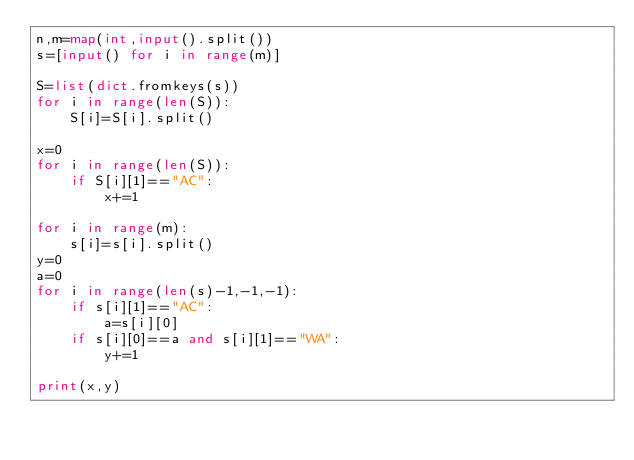<code> <loc_0><loc_0><loc_500><loc_500><_Python_>n,m=map(int,input().split())
s=[input() for i in range(m)]

S=list(dict.fromkeys(s))
for i in range(len(S)):
    S[i]=S[i].split()

x=0
for i in range(len(S)):
    if S[i][1]=="AC":
        x+=1

for i in range(m):
    s[i]=s[i].split()
y=0
a=0
for i in range(len(s)-1,-1,-1):
    if s[i][1]=="AC":
        a=s[i][0]
    if s[i][0]==a and s[i][1]=="WA":
        y+=1

print(x,y)</code> 